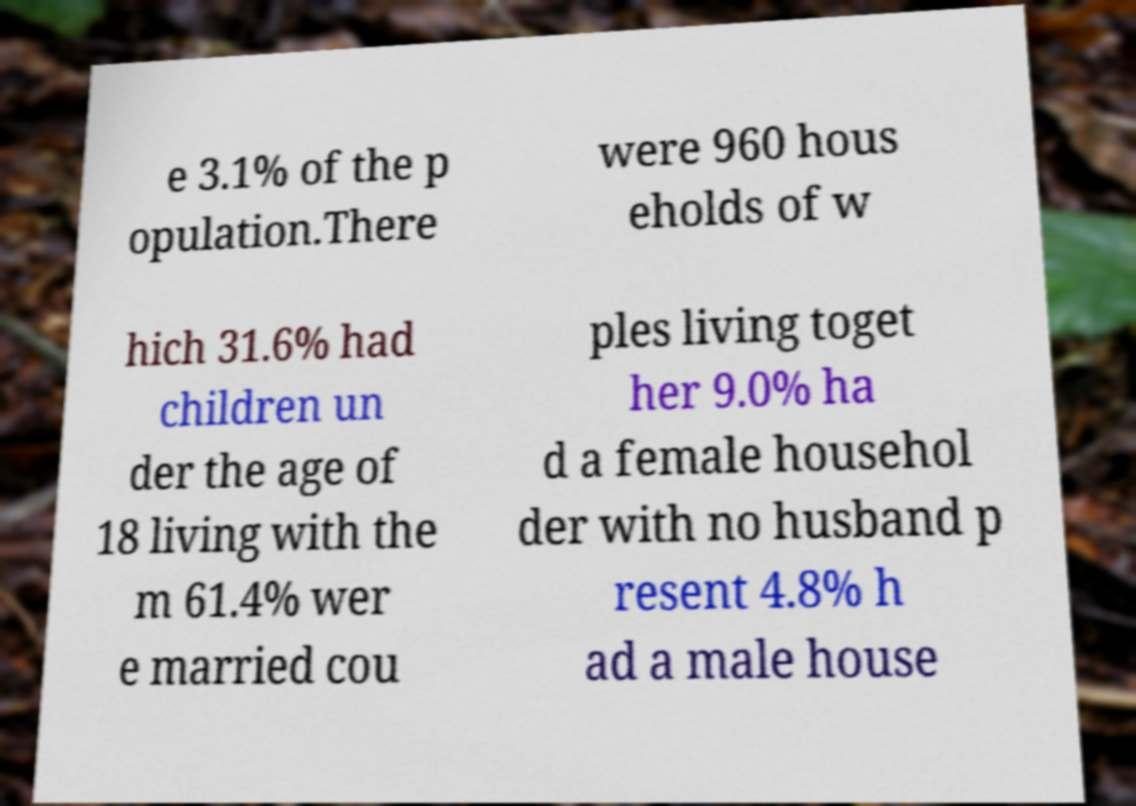I need the written content from this picture converted into text. Can you do that? e 3.1% of the p opulation.There were 960 hous eholds of w hich 31.6% had children un der the age of 18 living with the m 61.4% wer e married cou ples living toget her 9.0% ha d a female househol der with no husband p resent 4.8% h ad a male house 